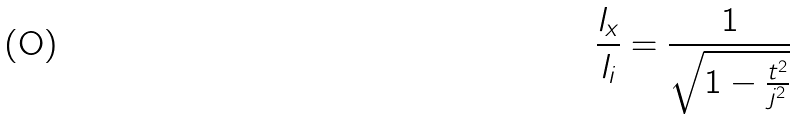<formula> <loc_0><loc_0><loc_500><loc_500>\frac { l _ { x } } { l _ { i } } = \frac { 1 } { \sqrt { 1 - \frac { t ^ { 2 } } { j ^ { 2 } } } }</formula> 